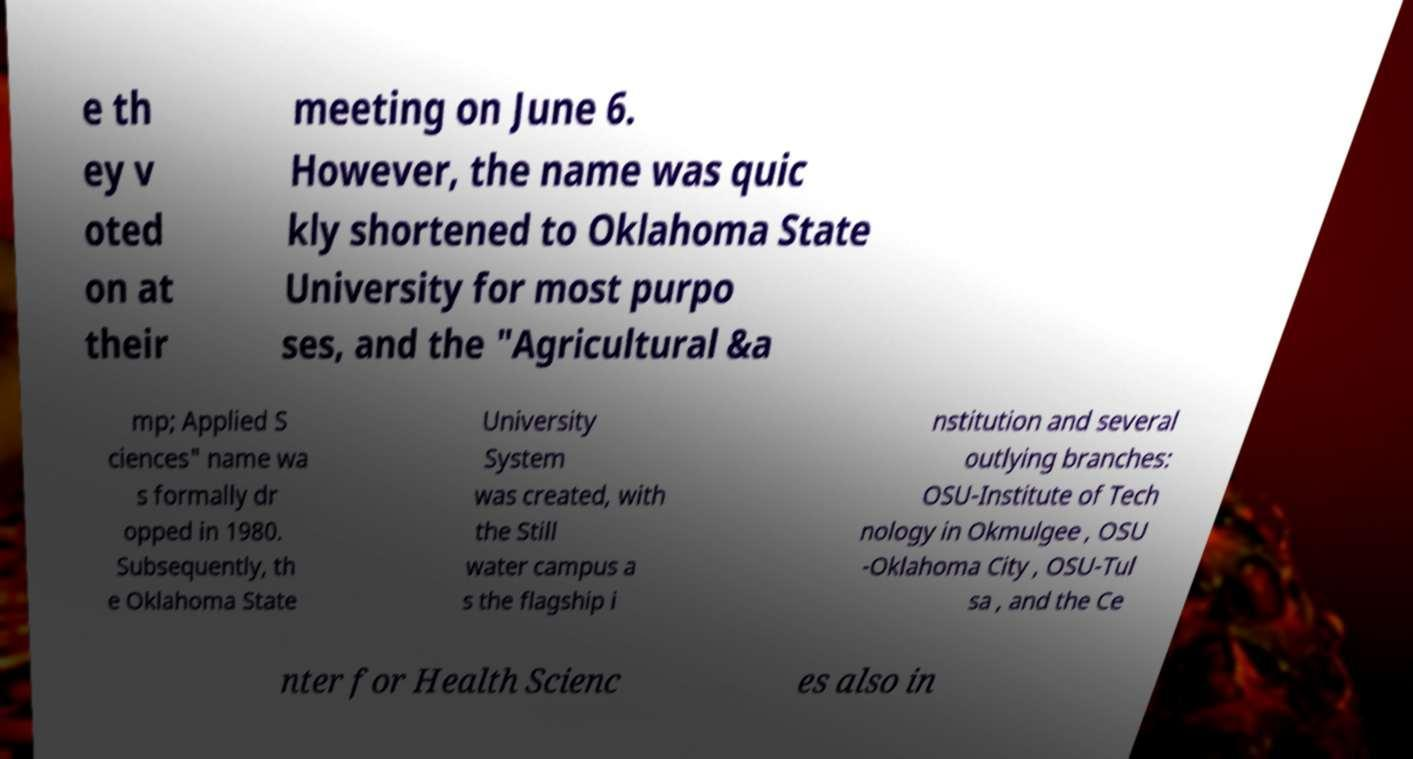Please read and relay the text visible in this image. What does it say? e th ey v oted on at their meeting on June 6. However, the name was quic kly shortened to Oklahoma State University for most purpo ses, and the "Agricultural &a mp; Applied S ciences" name wa s formally dr opped in 1980. Subsequently, th e Oklahoma State University System was created, with the Still water campus a s the flagship i nstitution and several outlying branches: OSU-Institute of Tech nology in Okmulgee , OSU -Oklahoma City , OSU-Tul sa , and the Ce nter for Health Scienc es also in 